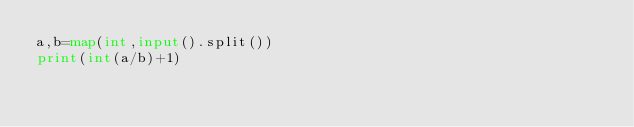<code> <loc_0><loc_0><loc_500><loc_500><_Python_>a,b=map(int,input().split())
print(int(a/b)+1)</code> 